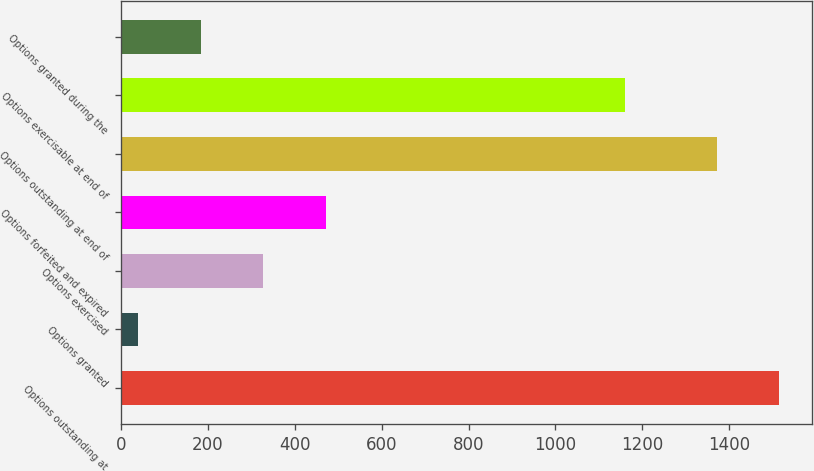Convert chart. <chart><loc_0><loc_0><loc_500><loc_500><bar_chart><fcel>Options outstanding at<fcel>Options granted<fcel>Options exercised<fcel>Options forfeited and expired<fcel>Options outstanding at end of<fcel>Options exercisable at end of<fcel>Options granted during the<nl><fcel>1515.1<fcel>40<fcel>328.2<fcel>472.3<fcel>1371<fcel>1160<fcel>184.1<nl></chart> 